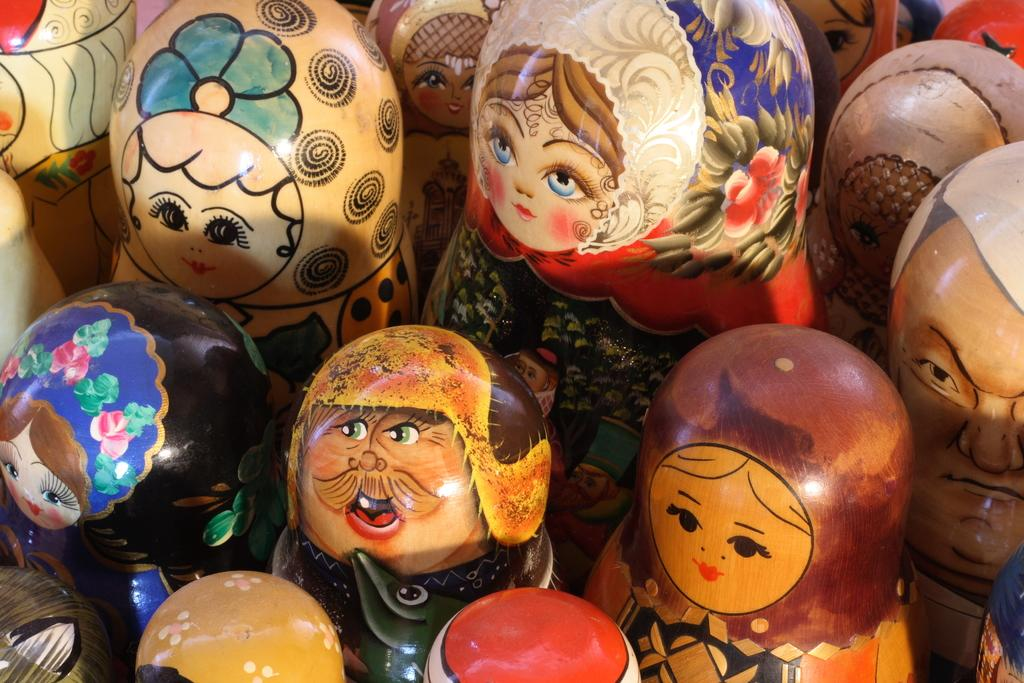What can be seen in the image? There is a group of objects in the image. What is depicted on the objects? There is art on the objects. What type of insect can be seen crawling on the edge of the objects in the image? There is no insect present in the image; it only features a group of objects with art on them. 